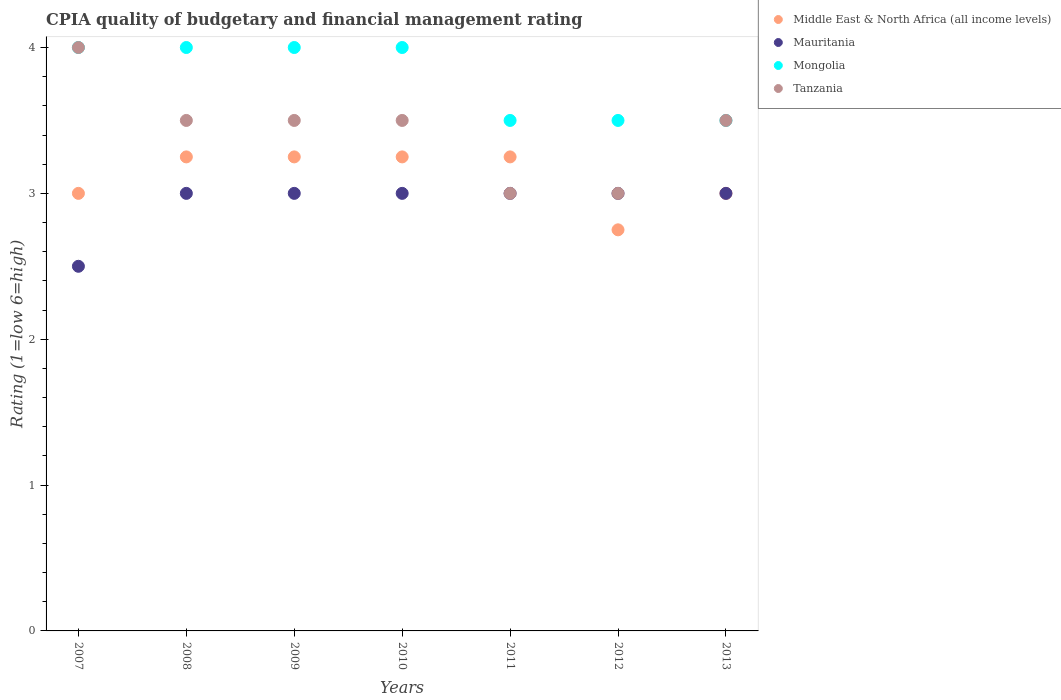Is the number of dotlines equal to the number of legend labels?
Make the answer very short. Yes. Across all years, what is the maximum CPIA rating in Middle East & North Africa (all income levels)?
Make the answer very short. 3.25. Across all years, what is the minimum CPIA rating in Middle East & North Africa (all income levels)?
Your response must be concise. 2.75. In which year was the CPIA rating in Mauritania minimum?
Your answer should be very brief. 2007. What is the total CPIA rating in Middle East & North Africa (all income levels) in the graph?
Provide a succinct answer. 21.75. What is the average CPIA rating in Mauritania per year?
Provide a succinct answer. 2.93. In the year 2012, what is the difference between the CPIA rating in Mongolia and CPIA rating in Mauritania?
Give a very brief answer. 0.5. In how many years, is the CPIA rating in Mongolia greater than 2?
Keep it short and to the point. 7. What is the ratio of the CPIA rating in Mongolia in 2010 to that in 2011?
Offer a terse response. 1.14. Is the CPIA rating in Tanzania in 2008 less than that in 2011?
Your response must be concise. No. What is the difference between the highest and the second highest CPIA rating in Mauritania?
Give a very brief answer. 0. What is the difference between the highest and the lowest CPIA rating in Middle East & North Africa (all income levels)?
Keep it short and to the point. 0.5. Is it the case that in every year, the sum of the CPIA rating in Mauritania and CPIA rating in Mongolia  is greater than the sum of CPIA rating in Middle East & North Africa (all income levels) and CPIA rating in Tanzania?
Give a very brief answer. Yes. Is the CPIA rating in Middle East & North Africa (all income levels) strictly greater than the CPIA rating in Tanzania over the years?
Provide a succinct answer. No. Are the values on the major ticks of Y-axis written in scientific E-notation?
Your response must be concise. No. Does the graph contain any zero values?
Offer a very short reply. No. Where does the legend appear in the graph?
Provide a succinct answer. Top right. What is the title of the graph?
Offer a terse response. CPIA quality of budgetary and financial management rating. Does "Brunei Darussalam" appear as one of the legend labels in the graph?
Your answer should be compact. No. What is the label or title of the X-axis?
Give a very brief answer. Years. What is the label or title of the Y-axis?
Give a very brief answer. Rating (1=low 6=high). What is the Rating (1=low 6=high) of Tanzania in 2007?
Your answer should be compact. 4. What is the Rating (1=low 6=high) of Middle East & North Africa (all income levels) in 2008?
Give a very brief answer. 3.25. What is the Rating (1=low 6=high) in Tanzania in 2008?
Keep it short and to the point. 3.5. What is the Rating (1=low 6=high) in Mongolia in 2009?
Provide a short and direct response. 4. What is the Rating (1=low 6=high) in Mongolia in 2010?
Provide a succinct answer. 4. What is the Rating (1=low 6=high) in Tanzania in 2010?
Keep it short and to the point. 3.5. What is the Rating (1=low 6=high) in Middle East & North Africa (all income levels) in 2011?
Offer a very short reply. 3.25. What is the Rating (1=low 6=high) in Mauritania in 2011?
Your answer should be compact. 3. What is the Rating (1=low 6=high) in Mongolia in 2011?
Keep it short and to the point. 3.5. What is the Rating (1=low 6=high) in Middle East & North Africa (all income levels) in 2012?
Provide a succinct answer. 2.75. What is the Rating (1=low 6=high) of Mauritania in 2012?
Provide a short and direct response. 3. What is the Rating (1=low 6=high) in Mongolia in 2012?
Your answer should be very brief. 3.5. What is the Rating (1=low 6=high) of Mauritania in 2013?
Make the answer very short. 3. Across all years, what is the maximum Rating (1=low 6=high) in Middle East & North Africa (all income levels)?
Offer a very short reply. 3.25. Across all years, what is the maximum Rating (1=low 6=high) of Mauritania?
Ensure brevity in your answer.  3. Across all years, what is the minimum Rating (1=low 6=high) in Middle East & North Africa (all income levels)?
Give a very brief answer. 2.75. Across all years, what is the minimum Rating (1=low 6=high) of Mongolia?
Provide a short and direct response. 3.5. Across all years, what is the minimum Rating (1=low 6=high) in Tanzania?
Provide a succinct answer. 3. What is the total Rating (1=low 6=high) of Middle East & North Africa (all income levels) in the graph?
Give a very brief answer. 21.75. What is the total Rating (1=low 6=high) in Mauritania in the graph?
Give a very brief answer. 20.5. What is the total Rating (1=low 6=high) of Mongolia in the graph?
Your response must be concise. 26.5. What is the difference between the Rating (1=low 6=high) in Mauritania in 2007 and that in 2008?
Provide a succinct answer. -0.5. What is the difference between the Rating (1=low 6=high) in Middle East & North Africa (all income levels) in 2007 and that in 2009?
Ensure brevity in your answer.  -0.25. What is the difference between the Rating (1=low 6=high) of Mauritania in 2007 and that in 2009?
Offer a very short reply. -0.5. What is the difference between the Rating (1=low 6=high) in Mongolia in 2007 and that in 2009?
Provide a succinct answer. 0. What is the difference between the Rating (1=low 6=high) of Mongolia in 2007 and that in 2010?
Offer a terse response. 0. What is the difference between the Rating (1=low 6=high) in Mongolia in 2007 and that in 2011?
Offer a very short reply. 0.5. What is the difference between the Rating (1=low 6=high) of Tanzania in 2007 and that in 2011?
Make the answer very short. 1. What is the difference between the Rating (1=low 6=high) in Mauritania in 2007 and that in 2012?
Your answer should be compact. -0.5. What is the difference between the Rating (1=low 6=high) of Mongolia in 2007 and that in 2012?
Offer a very short reply. 0.5. What is the difference between the Rating (1=low 6=high) of Tanzania in 2007 and that in 2012?
Ensure brevity in your answer.  1. What is the difference between the Rating (1=low 6=high) of Middle East & North Africa (all income levels) in 2007 and that in 2013?
Your answer should be compact. 0. What is the difference between the Rating (1=low 6=high) in Mongolia in 2007 and that in 2013?
Ensure brevity in your answer.  0.5. What is the difference between the Rating (1=low 6=high) in Tanzania in 2007 and that in 2013?
Provide a succinct answer. 0.5. What is the difference between the Rating (1=low 6=high) in Tanzania in 2008 and that in 2009?
Make the answer very short. 0. What is the difference between the Rating (1=low 6=high) in Middle East & North Africa (all income levels) in 2008 and that in 2010?
Your answer should be compact. 0. What is the difference between the Rating (1=low 6=high) of Mauritania in 2008 and that in 2010?
Give a very brief answer. 0. What is the difference between the Rating (1=low 6=high) in Mongolia in 2008 and that in 2010?
Give a very brief answer. 0. What is the difference between the Rating (1=low 6=high) in Middle East & North Africa (all income levels) in 2008 and that in 2011?
Make the answer very short. 0. What is the difference between the Rating (1=low 6=high) in Mongolia in 2008 and that in 2011?
Ensure brevity in your answer.  0.5. What is the difference between the Rating (1=low 6=high) of Mongolia in 2008 and that in 2012?
Provide a short and direct response. 0.5. What is the difference between the Rating (1=low 6=high) of Middle East & North Africa (all income levels) in 2008 and that in 2013?
Provide a short and direct response. 0.25. What is the difference between the Rating (1=low 6=high) of Mauritania in 2008 and that in 2013?
Offer a very short reply. 0. What is the difference between the Rating (1=low 6=high) in Mongolia in 2008 and that in 2013?
Give a very brief answer. 0.5. What is the difference between the Rating (1=low 6=high) of Middle East & North Africa (all income levels) in 2009 and that in 2010?
Give a very brief answer. 0. What is the difference between the Rating (1=low 6=high) in Mauritania in 2009 and that in 2010?
Your answer should be compact. 0. What is the difference between the Rating (1=low 6=high) of Mongolia in 2009 and that in 2010?
Your answer should be very brief. 0. What is the difference between the Rating (1=low 6=high) in Middle East & North Africa (all income levels) in 2009 and that in 2011?
Your answer should be compact. 0. What is the difference between the Rating (1=low 6=high) of Middle East & North Africa (all income levels) in 2009 and that in 2012?
Keep it short and to the point. 0.5. What is the difference between the Rating (1=low 6=high) of Mauritania in 2009 and that in 2012?
Your answer should be very brief. 0. What is the difference between the Rating (1=low 6=high) in Middle East & North Africa (all income levels) in 2010 and that in 2011?
Your answer should be compact. 0. What is the difference between the Rating (1=low 6=high) of Mauritania in 2010 and that in 2011?
Provide a succinct answer. 0. What is the difference between the Rating (1=low 6=high) in Tanzania in 2010 and that in 2011?
Provide a succinct answer. 0.5. What is the difference between the Rating (1=low 6=high) in Middle East & North Africa (all income levels) in 2010 and that in 2012?
Give a very brief answer. 0.5. What is the difference between the Rating (1=low 6=high) of Mauritania in 2010 and that in 2012?
Your answer should be compact. 0. What is the difference between the Rating (1=low 6=high) of Mongolia in 2010 and that in 2013?
Your answer should be very brief. 0.5. What is the difference between the Rating (1=low 6=high) of Tanzania in 2010 and that in 2013?
Your response must be concise. 0. What is the difference between the Rating (1=low 6=high) of Mongolia in 2011 and that in 2012?
Your answer should be compact. 0. What is the difference between the Rating (1=low 6=high) of Tanzania in 2011 and that in 2012?
Make the answer very short. 0. What is the difference between the Rating (1=low 6=high) in Mongolia in 2011 and that in 2013?
Keep it short and to the point. 0. What is the difference between the Rating (1=low 6=high) of Mongolia in 2012 and that in 2013?
Ensure brevity in your answer.  0. What is the difference between the Rating (1=low 6=high) in Tanzania in 2012 and that in 2013?
Ensure brevity in your answer.  -0.5. What is the difference between the Rating (1=low 6=high) in Middle East & North Africa (all income levels) in 2007 and the Rating (1=low 6=high) in Mongolia in 2008?
Make the answer very short. -1. What is the difference between the Rating (1=low 6=high) in Mongolia in 2007 and the Rating (1=low 6=high) in Tanzania in 2008?
Keep it short and to the point. 0.5. What is the difference between the Rating (1=low 6=high) of Middle East & North Africa (all income levels) in 2007 and the Rating (1=low 6=high) of Mongolia in 2009?
Ensure brevity in your answer.  -1. What is the difference between the Rating (1=low 6=high) in Middle East & North Africa (all income levels) in 2007 and the Rating (1=low 6=high) in Tanzania in 2009?
Your answer should be very brief. -0.5. What is the difference between the Rating (1=low 6=high) in Mauritania in 2007 and the Rating (1=low 6=high) in Mongolia in 2009?
Offer a very short reply. -1.5. What is the difference between the Rating (1=low 6=high) in Mauritania in 2007 and the Rating (1=low 6=high) in Tanzania in 2009?
Your response must be concise. -1. What is the difference between the Rating (1=low 6=high) in Middle East & North Africa (all income levels) in 2007 and the Rating (1=low 6=high) in Tanzania in 2010?
Make the answer very short. -0.5. What is the difference between the Rating (1=low 6=high) in Mauritania in 2007 and the Rating (1=low 6=high) in Tanzania in 2010?
Keep it short and to the point. -1. What is the difference between the Rating (1=low 6=high) of Middle East & North Africa (all income levels) in 2007 and the Rating (1=low 6=high) of Tanzania in 2011?
Give a very brief answer. 0. What is the difference between the Rating (1=low 6=high) in Mauritania in 2007 and the Rating (1=low 6=high) in Tanzania in 2011?
Make the answer very short. -0.5. What is the difference between the Rating (1=low 6=high) in Middle East & North Africa (all income levels) in 2007 and the Rating (1=low 6=high) in Mauritania in 2012?
Ensure brevity in your answer.  0. What is the difference between the Rating (1=low 6=high) of Middle East & North Africa (all income levels) in 2007 and the Rating (1=low 6=high) of Mongolia in 2012?
Give a very brief answer. -0.5. What is the difference between the Rating (1=low 6=high) of Middle East & North Africa (all income levels) in 2007 and the Rating (1=low 6=high) of Tanzania in 2012?
Give a very brief answer. 0. What is the difference between the Rating (1=low 6=high) in Middle East & North Africa (all income levels) in 2007 and the Rating (1=low 6=high) in Mauritania in 2013?
Your response must be concise. 0. What is the difference between the Rating (1=low 6=high) in Middle East & North Africa (all income levels) in 2007 and the Rating (1=low 6=high) in Mongolia in 2013?
Give a very brief answer. -0.5. What is the difference between the Rating (1=low 6=high) in Mauritania in 2007 and the Rating (1=low 6=high) in Tanzania in 2013?
Your answer should be very brief. -1. What is the difference between the Rating (1=low 6=high) in Mongolia in 2007 and the Rating (1=low 6=high) in Tanzania in 2013?
Keep it short and to the point. 0.5. What is the difference between the Rating (1=low 6=high) of Middle East & North Africa (all income levels) in 2008 and the Rating (1=low 6=high) of Mongolia in 2009?
Offer a terse response. -0.75. What is the difference between the Rating (1=low 6=high) in Middle East & North Africa (all income levels) in 2008 and the Rating (1=low 6=high) in Tanzania in 2009?
Provide a succinct answer. -0.25. What is the difference between the Rating (1=low 6=high) in Mauritania in 2008 and the Rating (1=low 6=high) in Mongolia in 2009?
Offer a very short reply. -1. What is the difference between the Rating (1=low 6=high) in Mongolia in 2008 and the Rating (1=low 6=high) in Tanzania in 2009?
Offer a terse response. 0.5. What is the difference between the Rating (1=low 6=high) in Middle East & North Africa (all income levels) in 2008 and the Rating (1=low 6=high) in Mongolia in 2010?
Offer a terse response. -0.75. What is the difference between the Rating (1=low 6=high) of Mauritania in 2008 and the Rating (1=low 6=high) of Tanzania in 2010?
Your answer should be very brief. -0.5. What is the difference between the Rating (1=low 6=high) of Mongolia in 2008 and the Rating (1=low 6=high) of Tanzania in 2010?
Your answer should be very brief. 0.5. What is the difference between the Rating (1=low 6=high) in Middle East & North Africa (all income levels) in 2008 and the Rating (1=low 6=high) in Tanzania in 2011?
Give a very brief answer. 0.25. What is the difference between the Rating (1=low 6=high) of Mauritania in 2008 and the Rating (1=low 6=high) of Tanzania in 2011?
Give a very brief answer. 0. What is the difference between the Rating (1=low 6=high) in Mongolia in 2008 and the Rating (1=low 6=high) in Tanzania in 2011?
Make the answer very short. 1. What is the difference between the Rating (1=low 6=high) of Middle East & North Africa (all income levels) in 2008 and the Rating (1=low 6=high) of Mauritania in 2012?
Your response must be concise. 0.25. What is the difference between the Rating (1=low 6=high) in Middle East & North Africa (all income levels) in 2008 and the Rating (1=low 6=high) in Mongolia in 2012?
Offer a very short reply. -0.25. What is the difference between the Rating (1=low 6=high) in Middle East & North Africa (all income levels) in 2008 and the Rating (1=low 6=high) in Tanzania in 2012?
Provide a succinct answer. 0.25. What is the difference between the Rating (1=low 6=high) of Middle East & North Africa (all income levels) in 2008 and the Rating (1=low 6=high) of Tanzania in 2013?
Ensure brevity in your answer.  -0.25. What is the difference between the Rating (1=low 6=high) in Mauritania in 2008 and the Rating (1=low 6=high) in Mongolia in 2013?
Give a very brief answer. -0.5. What is the difference between the Rating (1=low 6=high) of Middle East & North Africa (all income levels) in 2009 and the Rating (1=low 6=high) of Mongolia in 2010?
Provide a short and direct response. -0.75. What is the difference between the Rating (1=low 6=high) in Mauritania in 2009 and the Rating (1=low 6=high) in Tanzania in 2010?
Provide a succinct answer. -0.5. What is the difference between the Rating (1=low 6=high) of Middle East & North Africa (all income levels) in 2009 and the Rating (1=low 6=high) of Mauritania in 2011?
Offer a terse response. 0.25. What is the difference between the Rating (1=low 6=high) in Mauritania in 2009 and the Rating (1=low 6=high) in Mongolia in 2011?
Your answer should be very brief. -0.5. What is the difference between the Rating (1=low 6=high) in Mauritania in 2009 and the Rating (1=low 6=high) in Tanzania in 2011?
Ensure brevity in your answer.  0. What is the difference between the Rating (1=low 6=high) of Middle East & North Africa (all income levels) in 2009 and the Rating (1=low 6=high) of Mauritania in 2012?
Your answer should be very brief. 0.25. What is the difference between the Rating (1=low 6=high) in Middle East & North Africa (all income levels) in 2009 and the Rating (1=low 6=high) in Mongolia in 2012?
Your response must be concise. -0.25. What is the difference between the Rating (1=low 6=high) of Middle East & North Africa (all income levels) in 2009 and the Rating (1=low 6=high) of Tanzania in 2012?
Your answer should be very brief. 0.25. What is the difference between the Rating (1=low 6=high) of Mauritania in 2009 and the Rating (1=low 6=high) of Mongolia in 2012?
Provide a short and direct response. -0.5. What is the difference between the Rating (1=low 6=high) in Mongolia in 2009 and the Rating (1=low 6=high) in Tanzania in 2012?
Ensure brevity in your answer.  1. What is the difference between the Rating (1=low 6=high) of Middle East & North Africa (all income levels) in 2009 and the Rating (1=low 6=high) of Mongolia in 2013?
Offer a very short reply. -0.25. What is the difference between the Rating (1=low 6=high) of Mauritania in 2009 and the Rating (1=low 6=high) of Mongolia in 2013?
Provide a succinct answer. -0.5. What is the difference between the Rating (1=low 6=high) in Middle East & North Africa (all income levels) in 2010 and the Rating (1=low 6=high) in Mauritania in 2011?
Your answer should be very brief. 0.25. What is the difference between the Rating (1=low 6=high) in Middle East & North Africa (all income levels) in 2010 and the Rating (1=low 6=high) in Tanzania in 2011?
Offer a very short reply. 0.25. What is the difference between the Rating (1=low 6=high) in Mongolia in 2010 and the Rating (1=low 6=high) in Tanzania in 2011?
Your answer should be compact. 1. What is the difference between the Rating (1=low 6=high) in Middle East & North Africa (all income levels) in 2010 and the Rating (1=low 6=high) in Mauritania in 2012?
Keep it short and to the point. 0.25. What is the difference between the Rating (1=low 6=high) in Mauritania in 2010 and the Rating (1=low 6=high) in Mongolia in 2012?
Provide a short and direct response. -0.5. What is the difference between the Rating (1=low 6=high) of Mongolia in 2010 and the Rating (1=low 6=high) of Tanzania in 2012?
Offer a terse response. 1. What is the difference between the Rating (1=low 6=high) in Middle East & North Africa (all income levels) in 2010 and the Rating (1=low 6=high) in Mongolia in 2013?
Your response must be concise. -0.25. What is the difference between the Rating (1=low 6=high) in Middle East & North Africa (all income levels) in 2010 and the Rating (1=low 6=high) in Tanzania in 2013?
Keep it short and to the point. -0.25. What is the difference between the Rating (1=low 6=high) of Middle East & North Africa (all income levels) in 2011 and the Rating (1=low 6=high) of Mongolia in 2012?
Your answer should be very brief. -0.25. What is the difference between the Rating (1=low 6=high) in Middle East & North Africa (all income levels) in 2011 and the Rating (1=low 6=high) in Tanzania in 2012?
Ensure brevity in your answer.  0.25. What is the difference between the Rating (1=low 6=high) in Middle East & North Africa (all income levels) in 2011 and the Rating (1=low 6=high) in Mauritania in 2013?
Offer a very short reply. 0.25. What is the difference between the Rating (1=low 6=high) in Middle East & North Africa (all income levels) in 2011 and the Rating (1=low 6=high) in Mongolia in 2013?
Keep it short and to the point. -0.25. What is the difference between the Rating (1=low 6=high) in Middle East & North Africa (all income levels) in 2011 and the Rating (1=low 6=high) in Tanzania in 2013?
Your answer should be very brief. -0.25. What is the difference between the Rating (1=low 6=high) of Mauritania in 2011 and the Rating (1=low 6=high) of Tanzania in 2013?
Provide a short and direct response. -0.5. What is the difference between the Rating (1=low 6=high) of Mongolia in 2011 and the Rating (1=low 6=high) of Tanzania in 2013?
Your answer should be compact. 0. What is the difference between the Rating (1=low 6=high) of Middle East & North Africa (all income levels) in 2012 and the Rating (1=low 6=high) of Mongolia in 2013?
Ensure brevity in your answer.  -0.75. What is the difference between the Rating (1=low 6=high) of Middle East & North Africa (all income levels) in 2012 and the Rating (1=low 6=high) of Tanzania in 2013?
Your response must be concise. -0.75. What is the difference between the Rating (1=low 6=high) of Mongolia in 2012 and the Rating (1=low 6=high) of Tanzania in 2013?
Ensure brevity in your answer.  0. What is the average Rating (1=low 6=high) of Middle East & North Africa (all income levels) per year?
Your response must be concise. 3.11. What is the average Rating (1=low 6=high) in Mauritania per year?
Offer a very short reply. 2.93. What is the average Rating (1=low 6=high) in Mongolia per year?
Give a very brief answer. 3.79. What is the average Rating (1=low 6=high) of Tanzania per year?
Your answer should be very brief. 3.43. In the year 2007, what is the difference between the Rating (1=low 6=high) of Middle East & North Africa (all income levels) and Rating (1=low 6=high) of Mauritania?
Offer a terse response. 0.5. In the year 2007, what is the difference between the Rating (1=low 6=high) in Middle East & North Africa (all income levels) and Rating (1=low 6=high) in Mongolia?
Offer a very short reply. -1. In the year 2007, what is the difference between the Rating (1=low 6=high) of Mongolia and Rating (1=low 6=high) of Tanzania?
Provide a short and direct response. 0. In the year 2008, what is the difference between the Rating (1=low 6=high) of Middle East & North Africa (all income levels) and Rating (1=low 6=high) of Mauritania?
Your answer should be very brief. 0.25. In the year 2008, what is the difference between the Rating (1=low 6=high) in Middle East & North Africa (all income levels) and Rating (1=low 6=high) in Mongolia?
Offer a very short reply. -0.75. In the year 2008, what is the difference between the Rating (1=low 6=high) in Mauritania and Rating (1=low 6=high) in Tanzania?
Keep it short and to the point. -0.5. In the year 2008, what is the difference between the Rating (1=low 6=high) in Mongolia and Rating (1=low 6=high) in Tanzania?
Ensure brevity in your answer.  0.5. In the year 2009, what is the difference between the Rating (1=low 6=high) of Middle East & North Africa (all income levels) and Rating (1=low 6=high) of Mongolia?
Provide a short and direct response. -0.75. In the year 2009, what is the difference between the Rating (1=low 6=high) in Mauritania and Rating (1=low 6=high) in Tanzania?
Keep it short and to the point. -0.5. In the year 2009, what is the difference between the Rating (1=low 6=high) of Mongolia and Rating (1=low 6=high) of Tanzania?
Your answer should be compact. 0.5. In the year 2010, what is the difference between the Rating (1=low 6=high) of Middle East & North Africa (all income levels) and Rating (1=low 6=high) of Mongolia?
Your answer should be compact. -0.75. In the year 2010, what is the difference between the Rating (1=low 6=high) of Middle East & North Africa (all income levels) and Rating (1=low 6=high) of Tanzania?
Keep it short and to the point. -0.25. In the year 2010, what is the difference between the Rating (1=low 6=high) in Mauritania and Rating (1=low 6=high) in Mongolia?
Give a very brief answer. -1. In the year 2010, what is the difference between the Rating (1=low 6=high) in Mauritania and Rating (1=low 6=high) in Tanzania?
Your answer should be very brief. -0.5. In the year 2010, what is the difference between the Rating (1=low 6=high) in Mongolia and Rating (1=low 6=high) in Tanzania?
Your answer should be very brief. 0.5. In the year 2011, what is the difference between the Rating (1=low 6=high) of Middle East & North Africa (all income levels) and Rating (1=low 6=high) of Mauritania?
Offer a very short reply. 0.25. In the year 2011, what is the difference between the Rating (1=low 6=high) of Middle East & North Africa (all income levels) and Rating (1=low 6=high) of Mongolia?
Provide a succinct answer. -0.25. In the year 2012, what is the difference between the Rating (1=low 6=high) in Middle East & North Africa (all income levels) and Rating (1=low 6=high) in Mongolia?
Your answer should be very brief. -0.75. In the year 2012, what is the difference between the Rating (1=low 6=high) of Mauritania and Rating (1=low 6=high) of Tanzania?
Your answer should be very brief. 0. In the year 2012, what is the difference between the Rating (1=low 6=high) of Mongolia and Rating (1=low 6=high) of Tanzania?
Offer a very short reply. 0.5. In the year 2013, what is the difference between the Rating (1=low 6=high) of Middle East & North Africa (all income levels) and Rating (1=low 6=high) of Mongolia?
Your response must be concise. -0.5. In the year 2013, what is the difference between the Rating (1=low 6=high) in Middle East & North Africa (all income levels) and Rating (1=low 6=high) in Tanzania?
Offer a very short reply. -0.5. In the year 2013, what is the difference between the Rating (1=low 6=high) in Mongolia and Rating (1=low 6=high) in Tanzania?
Your response must be concise. 0. What is the ratio of the Rating (1=low 6=high) in Mongolia in 2007 to that in 2008?
Offer a very short reply. 1. What is the ratio of the Rating (1=low 6=high) in Middle East & North Africa (all income levels) in 2007 to that in 2009?
Keep it short and to the point. 0.92. What is the ratio of the Rating (1=low 6=high) in Mauritania in 2007 to that in 2009?
Keep it short and to the point. 0.83. What is the ratio of the Rating (1=low 6=high) in Mongolia in 2007 to that in 2009?
Give a very brief answer. 1. What is the ratio of the Rating (1=low 6=high) of Tanzania in 2007 to that in 2009?
Provide a succinct answer. 1.14. What is the ratio of the Rating (1=low 6=high) of Mongolia in 2007 to that in 2010?
Your response must be concise. 1. What is the ratio of the Rating (1=low 6=high) in Middle East & North Africa (all income levels) in 2007 to that in 2011?
Provide a succinct answer. 0.92. What is the ratio of the Rating (1=low 6=high) of Mauritania in 2007 to that in 2011?
Your response must be concise. 0.83. What is the ratio of the Rating (1=low 6=high) of Mongolia in 2007 to that in 2011?
Keep it short and to the point. 1.14. What is the ratio of the Rating (1=low 6=high) in Middle East & North Africa (all income levels) in 2007 to that in 2012?
Ensure brevity in your answer.  1.09. What is the ratio of the Rating (1=low 6=high) of Middle East & North Africa (all income levels) in 2007 to that in 2013?
Offer a terse response. 1. What is the ratio of the Rating (1=low 6=high) in Tanzania in 2007 to that in 2013?
Offer a terse response. 1.14. What is the ratio of the Rating (1=low 6=high) of Mauritania in 2008 to that in 2009?
Your answer should be very brief. 1. What is the ratio of the Rating (1=low 6=high) in Mongolia in 2008 to that in 2009?
Ensure brevity in your answer.  1. What is the ratio of the Rating (1=low 6=high) in Middle East & North Africa (all income levels) in 2008 to that in 2011?
Provide a succinct answer. 1. What is the ratio of the Rating (1=low 6=high) of Tanzania in 2008 to that in 2011?
Give a very brief answer. 1.17. What is the ratio of the Rating (1=low 6=high) in Middle East & North Africa (all income levels) in 2008 to that in 2012?
Your answer should be compact. 1.18. What is the ratio of the Rating (1=low 6=high) in Mauritania in 2008 to that in 2012?
Your response must be concise. 1. What is the ratio of the Rating (1=low 6=high) of Mongolia in 2008 to that in 2012?
Your answer should be very brief. 1.14. What is the ratio of the Rating (1=low 6=high) of Middle East & North Africa (all income levels) in 2008 to that in 2013?
Your answer should be compact. 1.08. What is the ratio of the Rating (1=low 6=high) in Mauritania in 2008 to that in 2013?
Give a very brief answer. 1. What is the ratio of the Rating (1=low 6=high) of Tanzania in 2008 to that in 2013?
Offer a very short reply. 1. What is the ratio of the Rating (1=low 6=high) in Middle East & North Africa (all income levels) in 2009 to that in 2010?
Make the answer very short. 1. What is the ratio of the Rating (1=low 6=high) of Mauritania in 2009 to that in 2011?
Your answer should be very brief. 1. What is the ratio of the Rating (1=low 6=high) of Middle East & North Africa (all income levels) in 2009 to that in 2012?
Make the answer very short. 1.18. What is the ratio of the Rating (1=low 6=high) of Mauritania in 2009 to that in 2012?
Keep it short and to the point. 1. What is the ratio of the Rating (1=low 6=high) in Mongolia in 2009 to that in 2012?
Offer a terse response. 1.14. What is the ratio of the Rating (1=low 6=high) of Mongolia in 2010 to that in 2011?
Your answer should be very brief. 1.14. What is the ratio of the Rating (1=low 6=high) of Tanzania in 2010 to that in 2011?
Keep it short and to the point. 1.17. What is the ratio of the Rating (1=low 6=high) of Middle East & North Africa (all income levels) in 2010 to that in 2012?
Give a very brief answer. 1.18. What is the ratio of the Rating (1=low 6=high) of Middle East & North Africa (all income levels) in 2010 to that in 2013?
Keep it short and to the point. 1.08. What is the ratio of the Rating (1=low 6=high) of Mauritania in 2010 to that in 2013?
Keep it short and to the point. 1. What is the ratio of the Rating (1=low 6=high) in Tanzania in 2010 to that in 2013?
Your answer should be compact. 1. What is the ratio of the Rating (1=low 6=high) of Middle East & North Africa (all income levels) in 2011 to that in 2012?
Offer a very short reply. 1.18. What is the ratio of the Rating (1=low 6=high) of Tanzania in 2011 to that in 2012?
Ensure brevity in your answer.  1. What is the ratio of the Rating (1=low 6=high) in Mauritania in 2011 to that in 2013?
Your answer should be compact. 1. What is the ratio of the Rating (1=low 6=high) of Mongolia in 2011 to that in 2013?
Provide a short and direct response. 1. What is the ratio of the Rating (1=low 6=high) in Tanzania in 2011 to that in 2013?
Your answer should be compact. 0.86. What is the ratio of the Rating (1=low 6=high) of Middle East & North Africa (all income levels) in 2012 to that in 2013?
Make the answer very short. 0.92. What is the ratio of the Rating (1=low 6=high) in Mauritania in 2012 to that in 2013?
Ensure brevity in your answer.  1. What is the ratio of the Rating (1=low 6=high) of Mongolia in 2012 to that in 2013?
Give a very brief answer. 1. What is the difference between the highest and the second highest Rating (1=low 6=high) of Mauritania?
Provide a succinct answer. 0. What is the difference between the highest and the lowest Rating (1=low 6=high) in Mongolia?
Make the answer very short. 0.5. What is the difference between the highest and the lowest Rating (1=low 6=high) of Tanzania?
Your answer should be very brief. 1. 